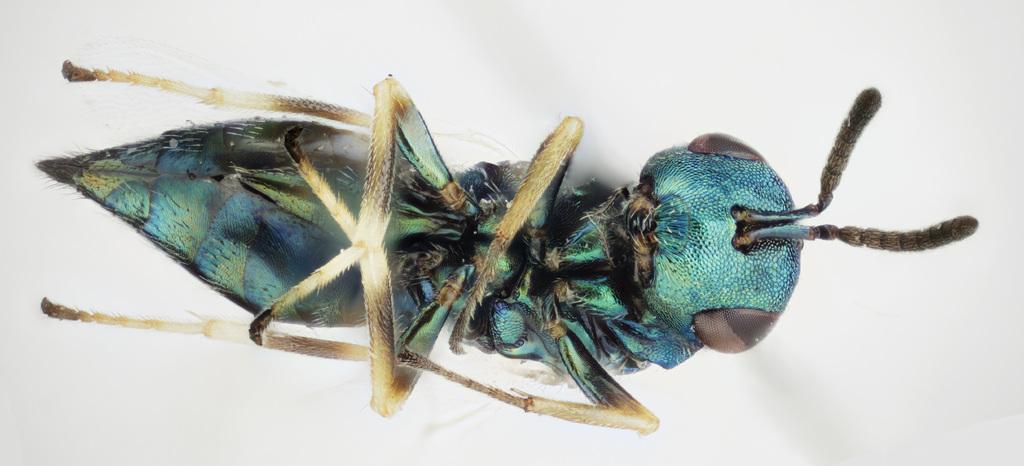What type of creature is present in the image? There is an insect in the image. What is the background or surface that the insect is on? The insect is on a white surface. Where is the insect located in the image? The insect is located in the middle of the image. What type of cake is being served in the image? There is no cake present in the image; it features an insect on a white surface. Can you describe the banana that the insect is holding in the image? There is no banana present in the image, and the insect is not holding anything. 